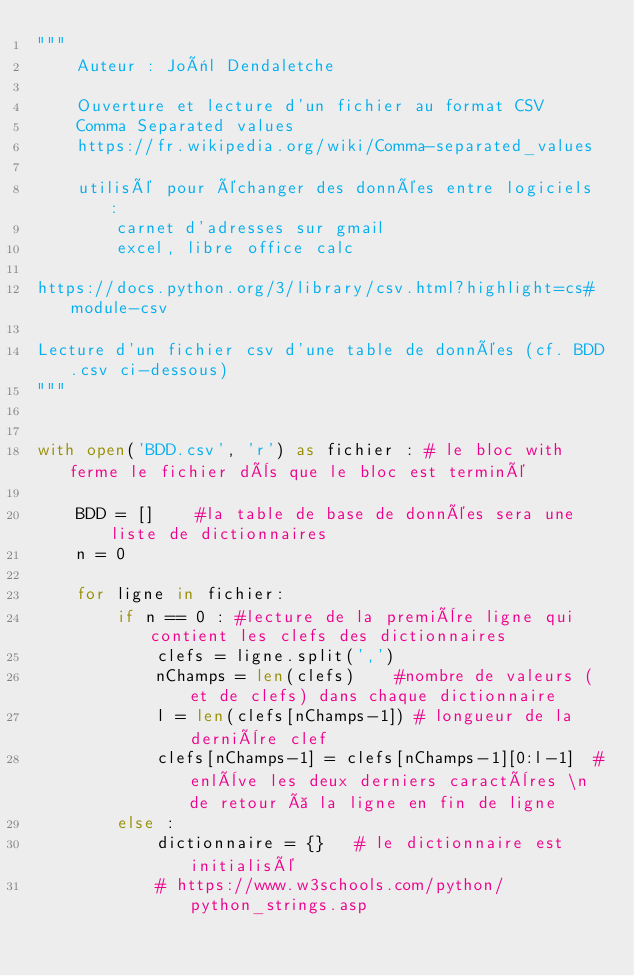<code> <loc_0><loc_0><loc_500><loc_500><_Python_>"""
    Auteur : Joël Dendaletche

    Ouverture et lecture d'un fichier au format CSV
    Comma Separated values
    https://fr.wikipedia.org/wiki/Comma-separated_values

    utilisé pour échanger des données entre logiciels :
        carnet d'adresses sur gmail
        excel, libre office calc
        
https://docs.python.org/3/library/csv.html?highlight=cs#module-csv

Lecture d'un fichier csv d'une table de données (cf. BDD.csv ci-dessous)
"""


with open('BDD.csv', 'r') as fichier : # le bloc with ferme le fichier dès que le bloc est terminé
    
    BDD = []    #la table de base de données sera une liste de dictionnaires
    n = 0

    for ligne in fichier:
        if n == 0 : #lecture de la première ligne qui contient les clefs des dictionnaires
            clefs = ligne.split(',')
            nChamps = len(clefs)    #nombre de valeurs (et de clefs) dans chaque dictionnaire
            l = len(clefs[nChamps-1]) # longueur de la dernière clef
            clefs[nChamps-1] = clefs[nChamps-1][0:l-1]  #enlève les deux derniers caractères \n de retour à la ligne en fin de ligne
        else : 
            dictionnaire = {}   # le dictionnaire est initialisé
            # https://www.w3schools.com/python/python_strings.asp</code> 